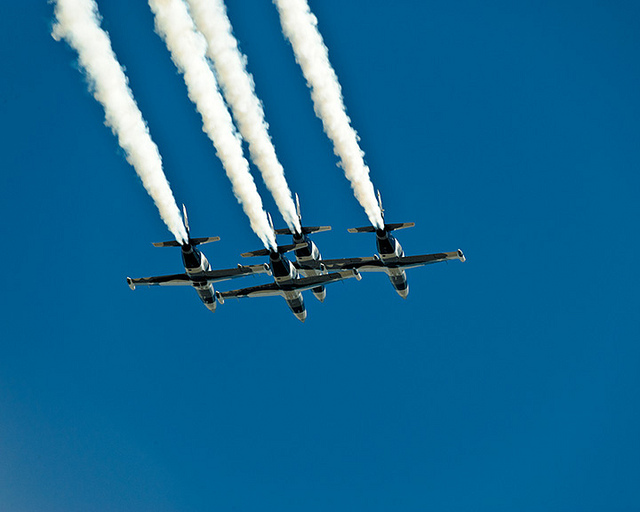<image>What flying team is this? I am not sure what flying team this is. It could be 'blue angels' or 'air force'. What flying team is this? I am not sure what flying team this is. It can be the Blue Angels or the Angels. 